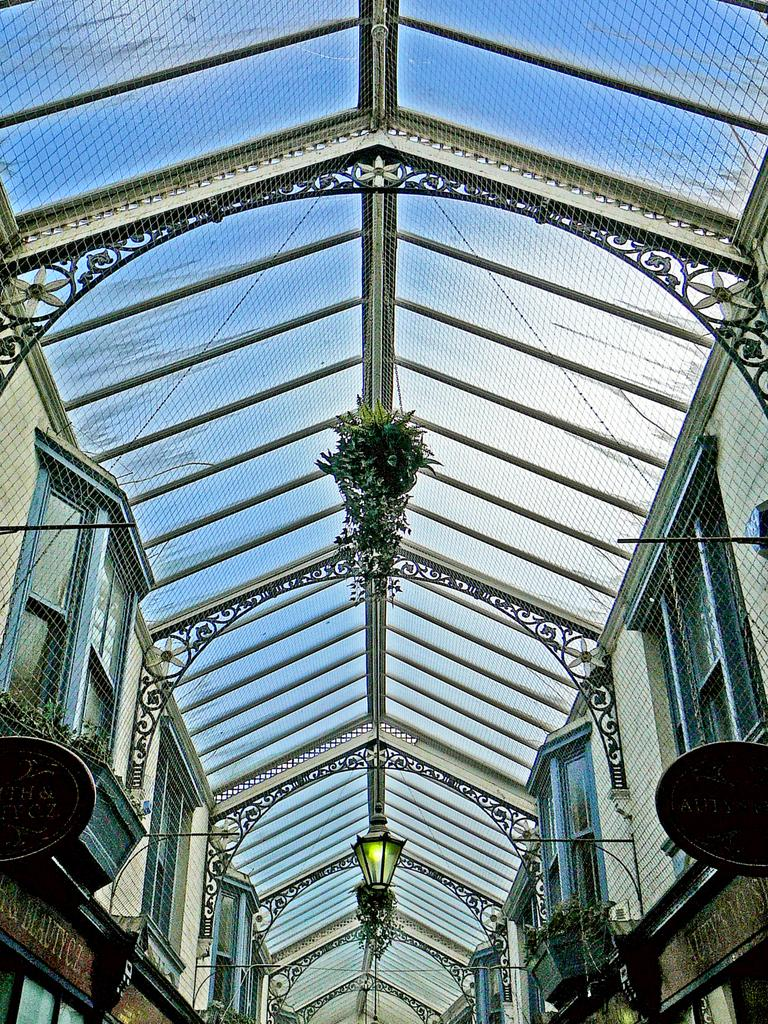What is on top of the structure in the image? There is a roof with a mesh fence on the top. What can be seen hanging from the ceiling in the image? There are lamps and plants hanging from the ceiling. What is visible on the balconies beneath the roof? There are windows on the balconies beneath the roof. What type of prose is being recited by the bears in the image? There are no bears or prose present in the image. How is the paste being used in the image? There is no paste present in the image. 